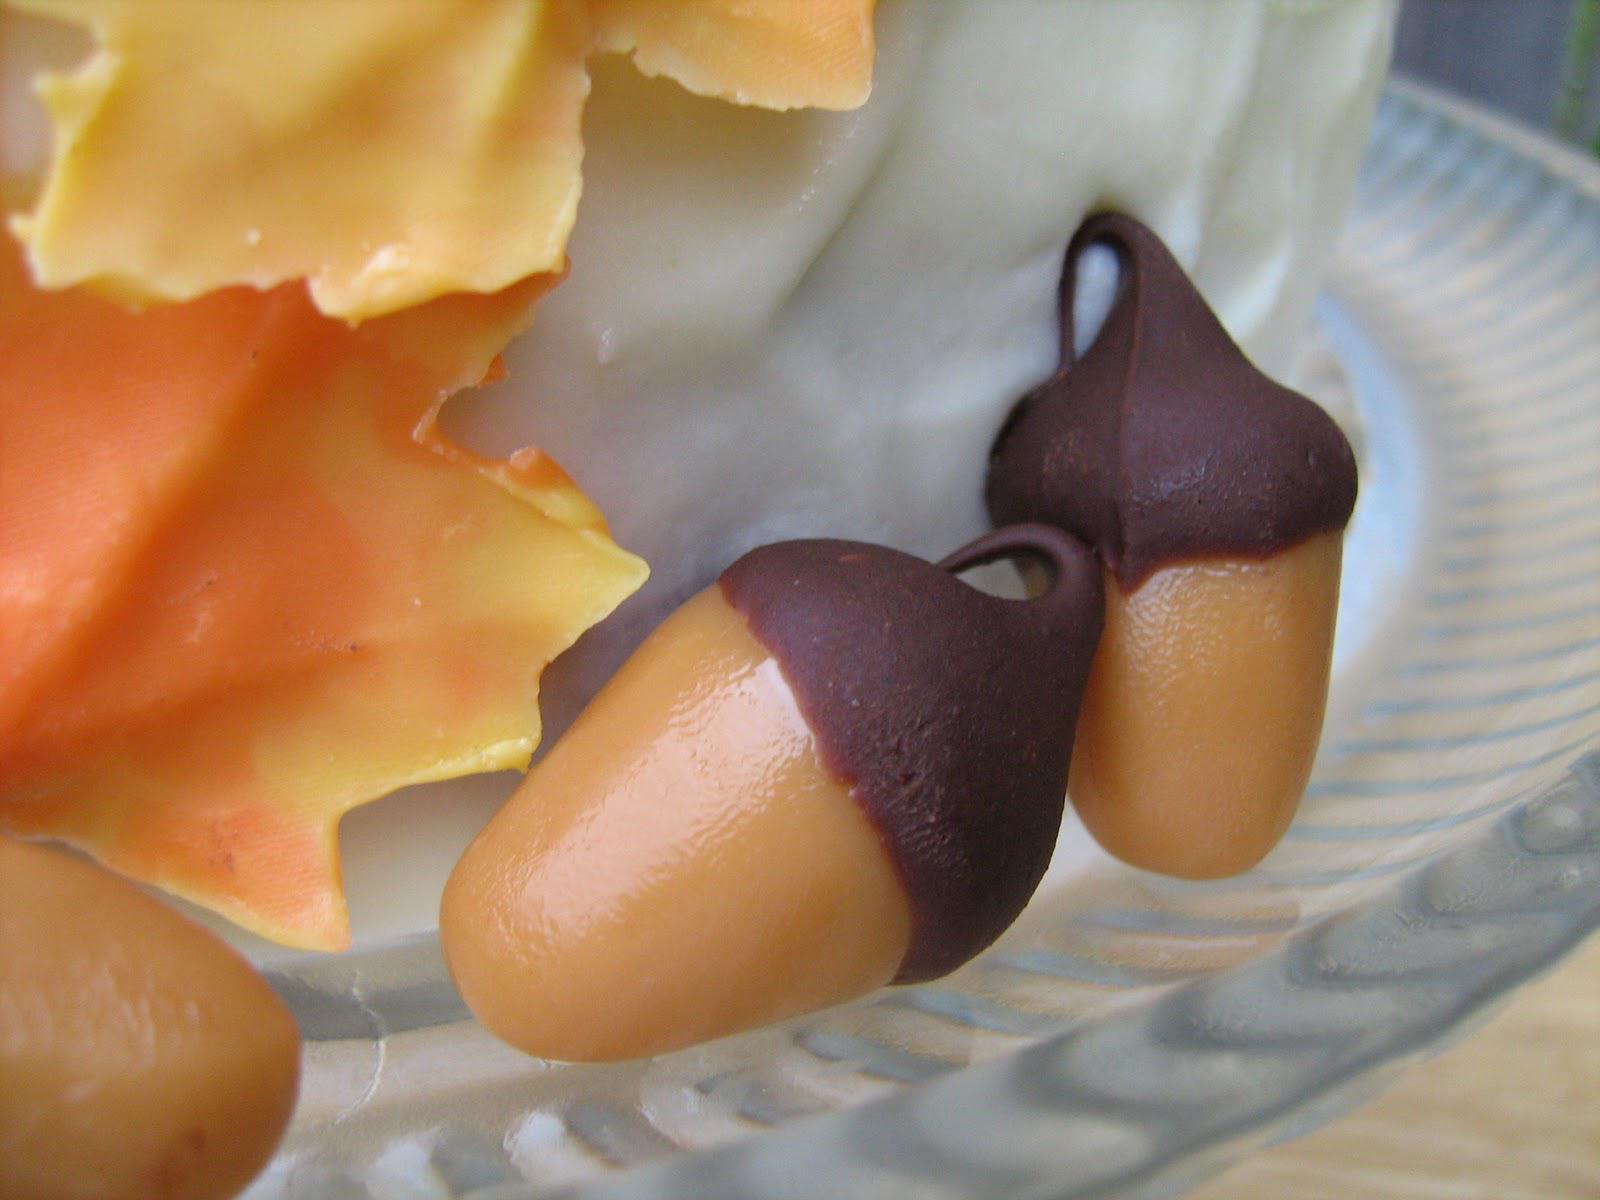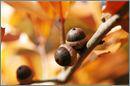The first image is the image on the left, the second image is the image on the right. Analyze the images presented: Is the assertion "There are five real acorns." valid? Answer yes or no. No. The first image is the image on the left, the second image is the image on the right. For the images shown, is this caption "The acorns in one of the images are green, while the acorns in the other image are brown." true? Answer yes or no. No. 